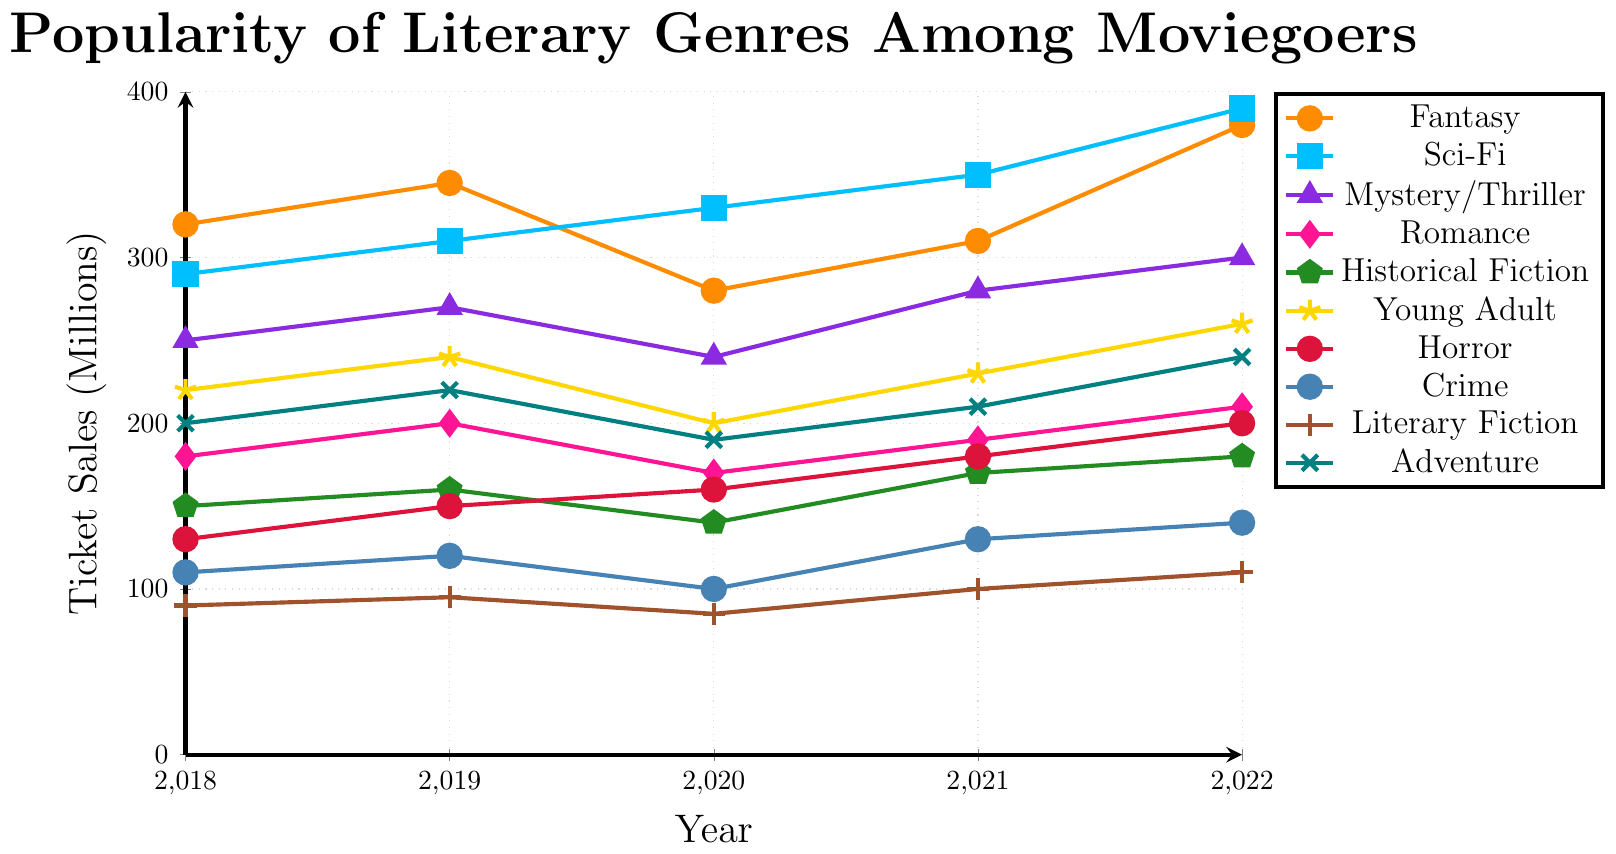Which genre had the highest ticket sales in 2022? To find the genre with the highest ticket sales in 2022, look at the y-values for each genre at the 2022 x-coordinate. Sci-Fi has the highest mark.
Answer: Sci-Fi How much did ticket sales for Fantasy increase from 2020 to 2022? First, find the ticket sales for Fantasy in 2020 and 2022, which are 280 and 380 respectively. Then, subtract the 2020 value from the 2022 value: 380 - 280 = 100.
Answer: 100 Which genre showed the most consistent year-over-year increase in ticket sales from 2018 to 2022? To determine which genre showed the most consistent increase, look at the slopes of the lines for each genre across the years. Sci-Fi consistently goes upwards without any year-over-year decline.
Answer: Sci-Fi What was the average ticket sales for Horror over the five-year period? Sum the ticket sales for Horror over the five years (130 + 150 + 160 + 180 + 200 = 820) and divide by 5: 820 / 5.
Answer: 164 Which two genres had the lowest ticket sales in 2020, and how do they compare? Compare the y-values for each genre at the 2020 x-coordinate. Crime and Literary Fiction have the lowest tickets sales at 100 and 85 respectively.
Answer: Crime, Literary Fiction; Crime > Literary Fiction What is the total ticket sales for Romance from 2018 to 2022? Sum the values for Romance: 180 + 200 + 170 + 190 + 210 = 950.
Answer: 950 Which genre had the highest increase in ticket sales from 2018 to 2022? Calculate the increase for each genre over the period and see which has the highest difference. Sci-Fi increased from 290 to 390, a 100 million increase, which is the highest.
Answer: Sci-Fi How did the popularity of Young Adult change from 2020 to 2022? Look at the ticket sales for Young Adult in 2020 and 2022: 200 and 260 respectively. The sales increased by 60 million (260 - 200).
Answer: Increase by 60 million Which genre had a ticket sales dip in 2020 and then recovered in 2021? Compare the 2020 and 2021 values for a dip and then recovery. Fantasy had a dip from 345 to 280 in 2020 and recovered to 310 in 2021.
Answer: Fantasy 